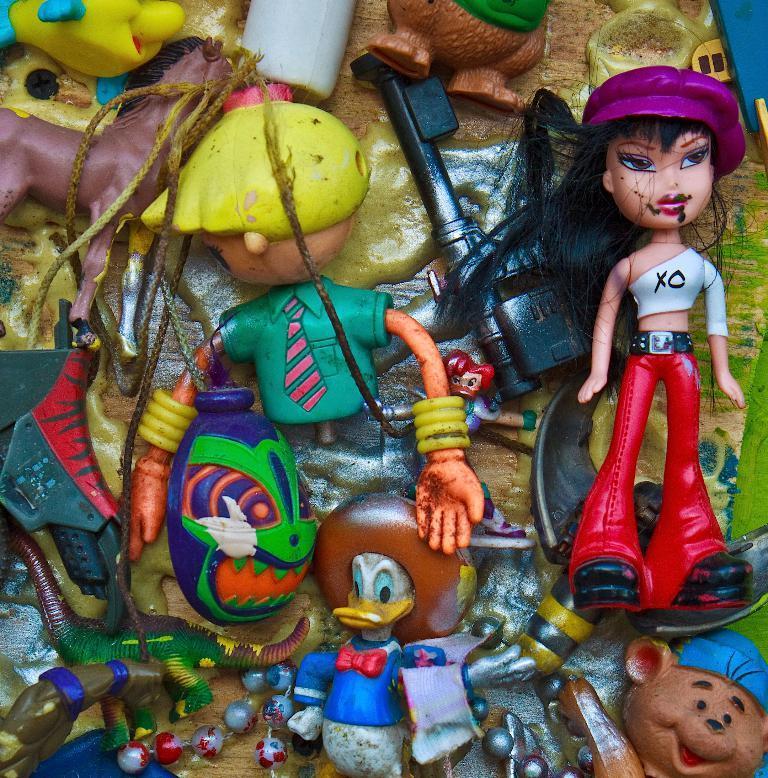How would you summarize this image in a sentence or two? In this picture we can see many toys in the image. In the front we can see doll, Donald duck and horse. 